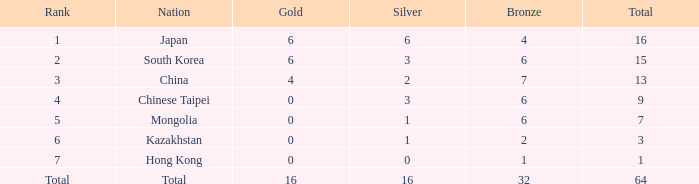Which state has 0 gold, and a bronze less than 6, and a standing of 6? Kazakhstan. 